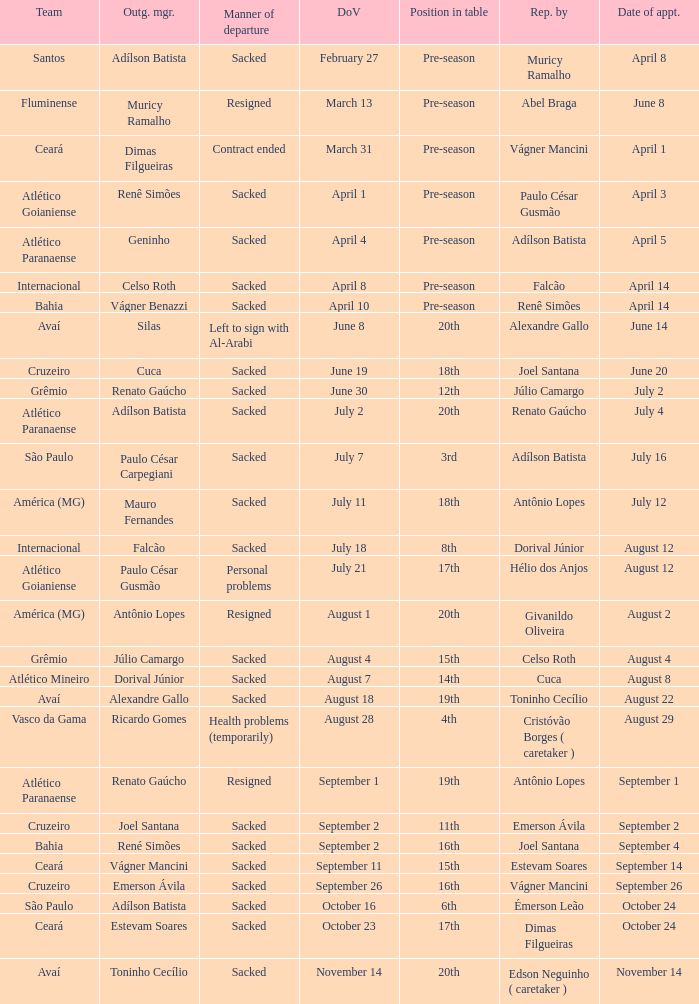Who was replaced as manager on June 20? Cuca. 